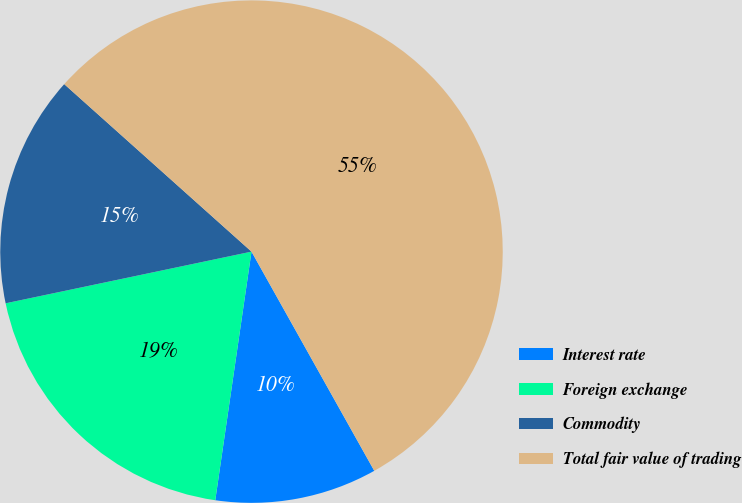Convert chart. <chart><loc_0><loc_0><loc_500><loc_500><pie_chart><fcel>Interest rate<fcel>Foreign exchange<fcel>Commodity<fcel>Total fair value of trading<nl><fcel>10.43%<fcel>19.4%<fcel>14.91%<fcel>55.26%<nl></chart> 